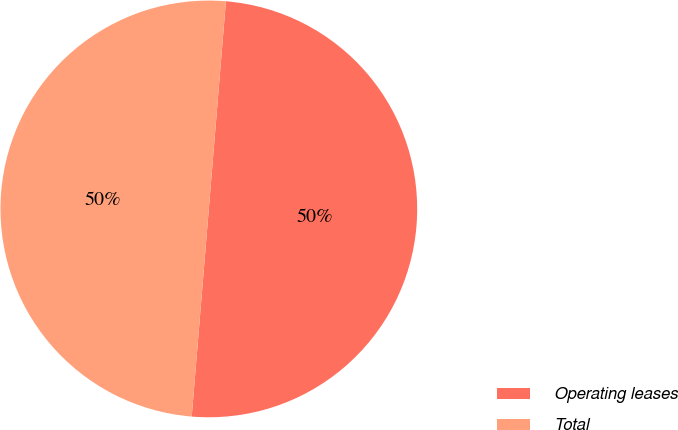Convert chart to OTSL. <chart><loc_0><loc_0><loc_500><loc_500><pie_chart><fcel>Operating leases<fcel>Total<nl><fcel>50.0%<fcel>50.0%<nl></chart> 